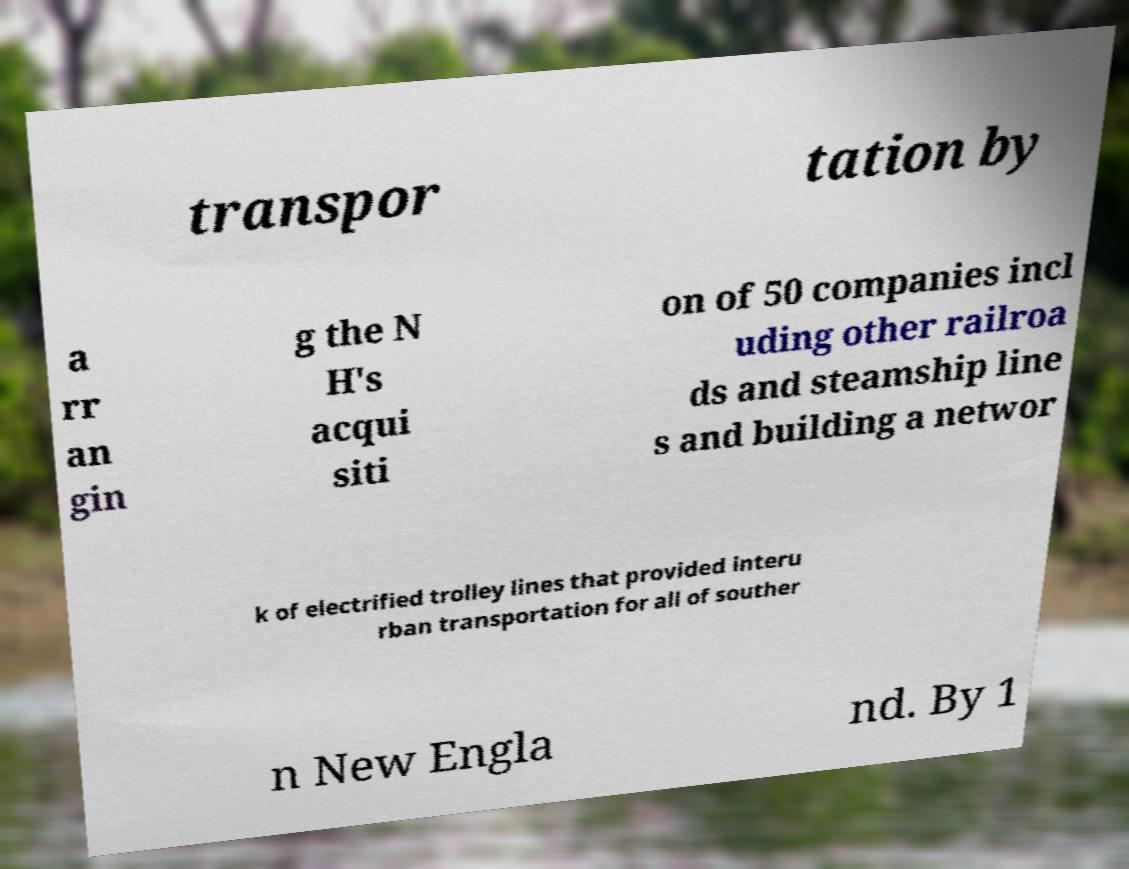There's text embedded in this image that I need extracted. Can you transcribe it verbatim? transpor tation by a rr an gin g the N H's acqui siti on of 50 companies incl uding other railroa ds and steamship line s and building a networ k of electrified trolley lines that provided interu rban transportation for all of souther n New Engla nd. By 1 